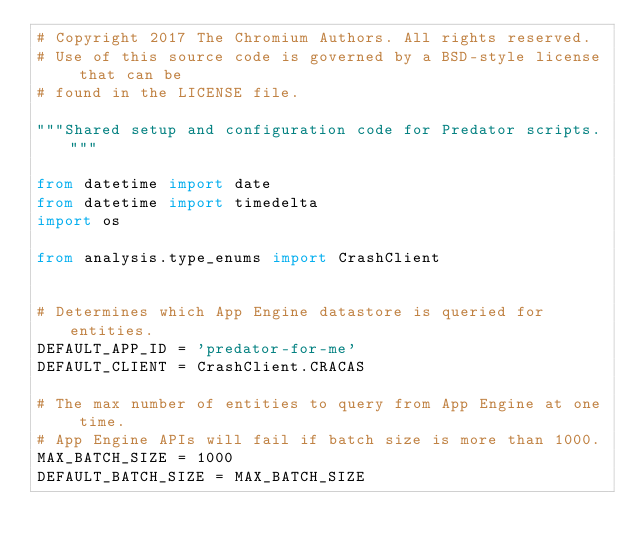Convert code to text. <code><loc_0><loc_0><loc_500><loc_500><_Python_># Copyright 2017 The Chromium Authors. All rights reserved.
# Use of this source code is governed by a BSD-style license that can be
# found in the LICENSE file.

"""Shared setup and configuration code for Predator scripts."""

from datetime import date
from datetime import timedelta
import os

from analysis.type_enums import CrashClient


# Determines which App Engine datastore is queried for entities.
DEFAULT_APP_ID = 'predator-for-me'
DEFAULT_CLIENT = CrashClient.CRACAS

# The max number of entities to query from App Engine at one time.
# App Engine APIs will fail if batch size is more than 1000.
MAX_BATCH_SIZE = 1000
DEFAULT_BATCH_SIZE = MAX_BATCH_SIZE
</code> 